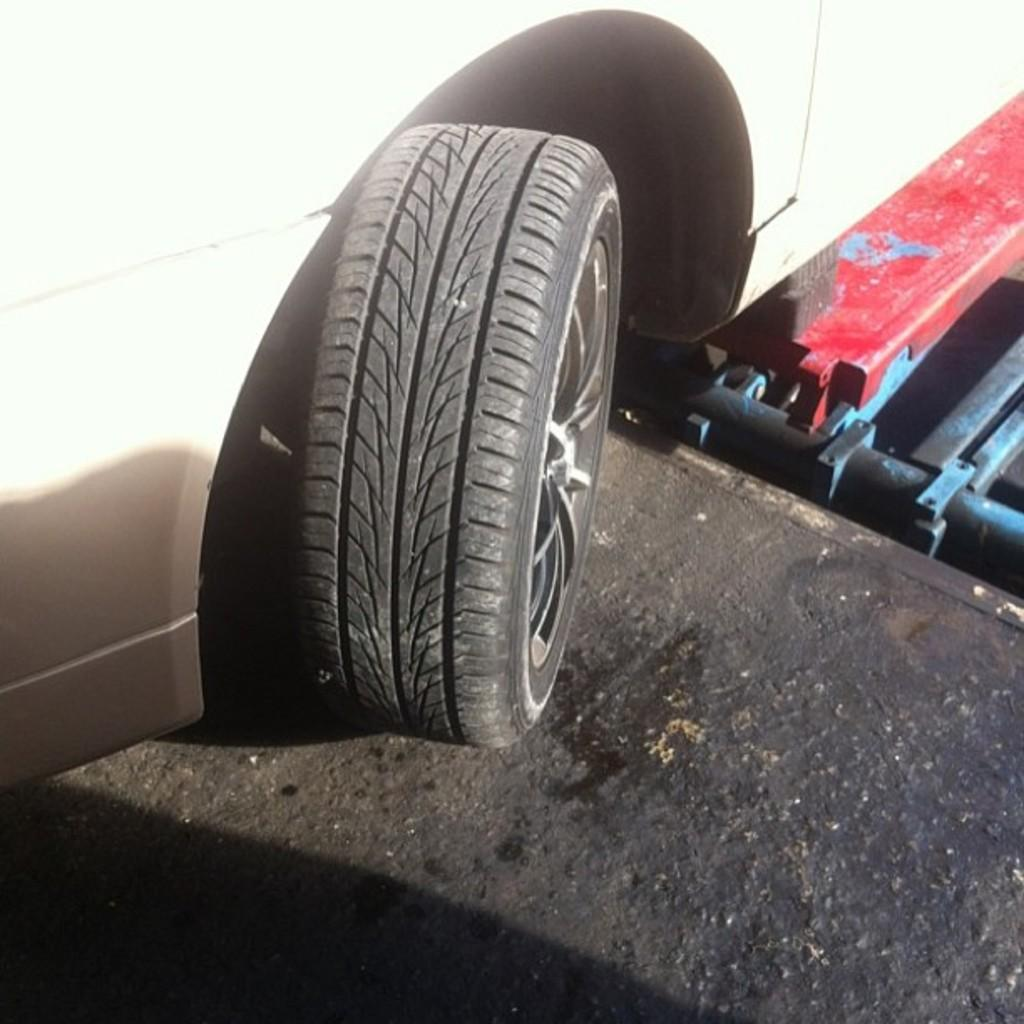What type of vehicle is in the image? There is a vehicle in the image, but the specific type is not mentioned in the facts. What feature does the vehicle have? The vehicle has wheels. Where is the vehicle located in the image? The vehicle is on a path. What can be found on the right side of the path? There are iron tools on the right side of the path. What type of headwear is the vehicle wearing in the image? Vehicles do not wear headwear, as they are inanimate objects. 